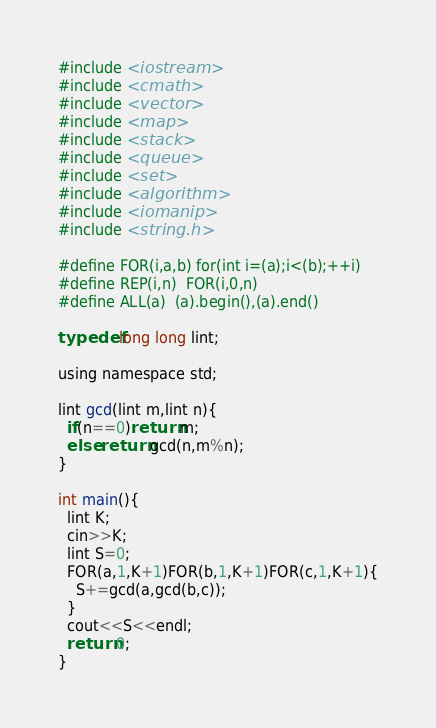<code> <loc_0><loc_0><loc_500><loc_500><_C_>#include <iostream>
#include <cmath>
#include <vector>
#include <map>
#include <stack>
#include <queue>
#include <set>
#include <algorithm>
#include <iomanip>
#include <string.h>

#define FOR(i,a,b) for(int i=(a);i<(b);++i)
#define REP(i,n)  FOR(i,0,n)
#define ALL(a)  (a).begin(),(a).end()

typedef long long lint;

using namespace std;

lint gcd(lint m,lint n){
  if(n==0)return m;
  else return gcd(n,m%n);
}

int main(){
  lint K;
  cin>>K;
  lint S=0;
  FOR(a,1,K+1)FOR(b,1,K+1)FOR(c,1,K+1){
    S+=gcd(a,gcd(b,c));
  }
  cout<<S<<endl;
  return 0;
}
</code> 